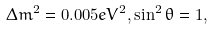<formula> <loc_0><loc_0><loc_500><loc_500>\Delta m ^ { 2 } = 0 . 0 0 5 e V ^ { 2 } , \sin ^ { 2 } \theta = 1 ,</formula> 